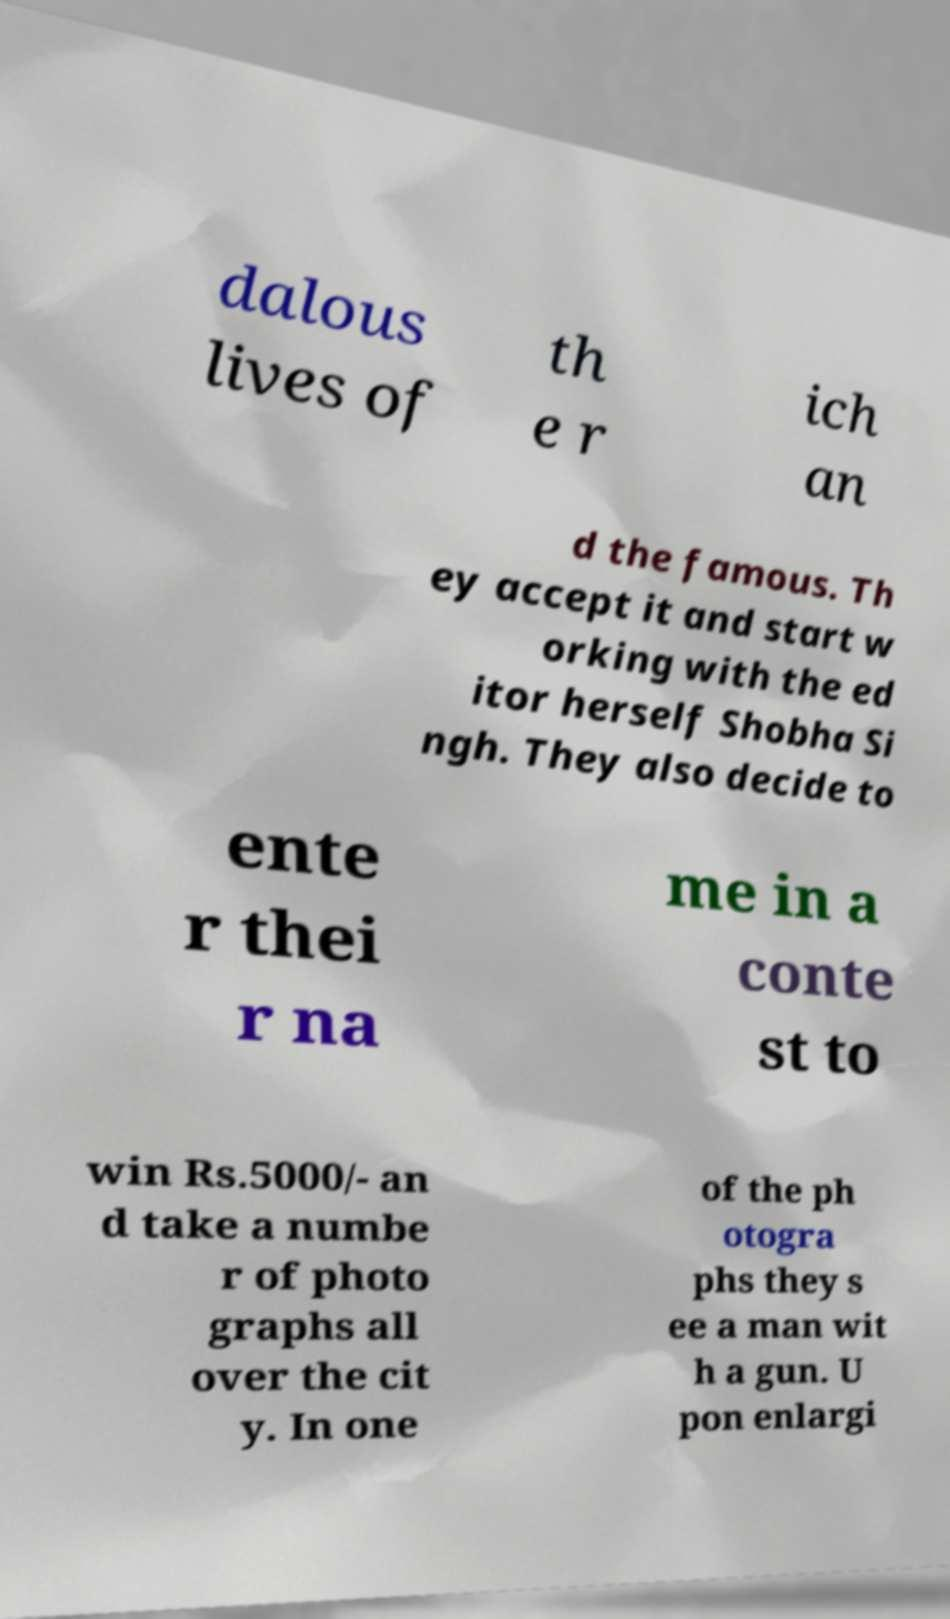There's text embedded in this image that I need extracted. Can you transcribe it verbatim? dalous lives of th e r ich an d the famous. Th ey accept it and start w orking with the ed itor herself Shobha Si ngh. They also decide to ente r thei r na me in a conte st to win Rs.5000/- an d take a numbe r of photo graphs all over the cit y. In one of the ph otogra phs they s ee a man wit h a gun. U pon enlargi 